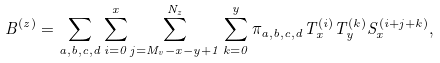<formula> <loc_0><loc_0><loc_500><loc_500>B ^ { ( z ) } = \sum _ { a , b , c , d } \sum _ { i = 0 } ^ { x } \sum _ { j = M _ { v } - x - y + 1 } ^ { N _ { z } } \sum _ { k = 0 } ^ { y } \pi _ { a , b , c , d } T _ { x } ^ { ( i ) } T _ { y } ^ { ( k ) } S _ { x } ^ { ( i + j + k ) } ,</formula> 